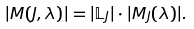<formula> <loc_0><loc_0><loc_500><loc_500>| M ( J , \lambda ) | = | \mathbb { L } _ { J } | \cdot | M _ { J } ( \lambda ) | .</formula> 